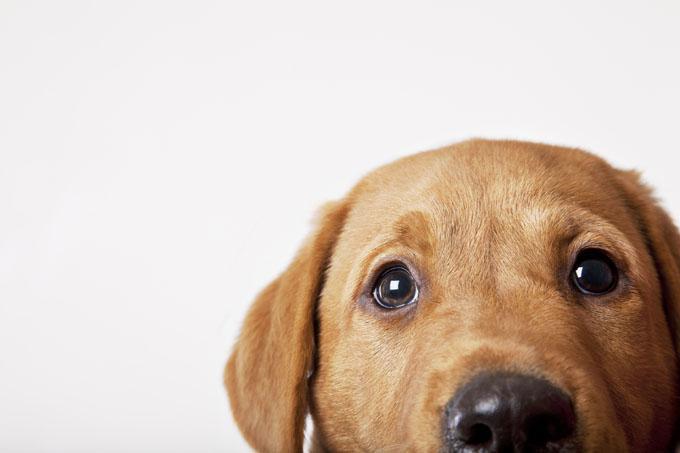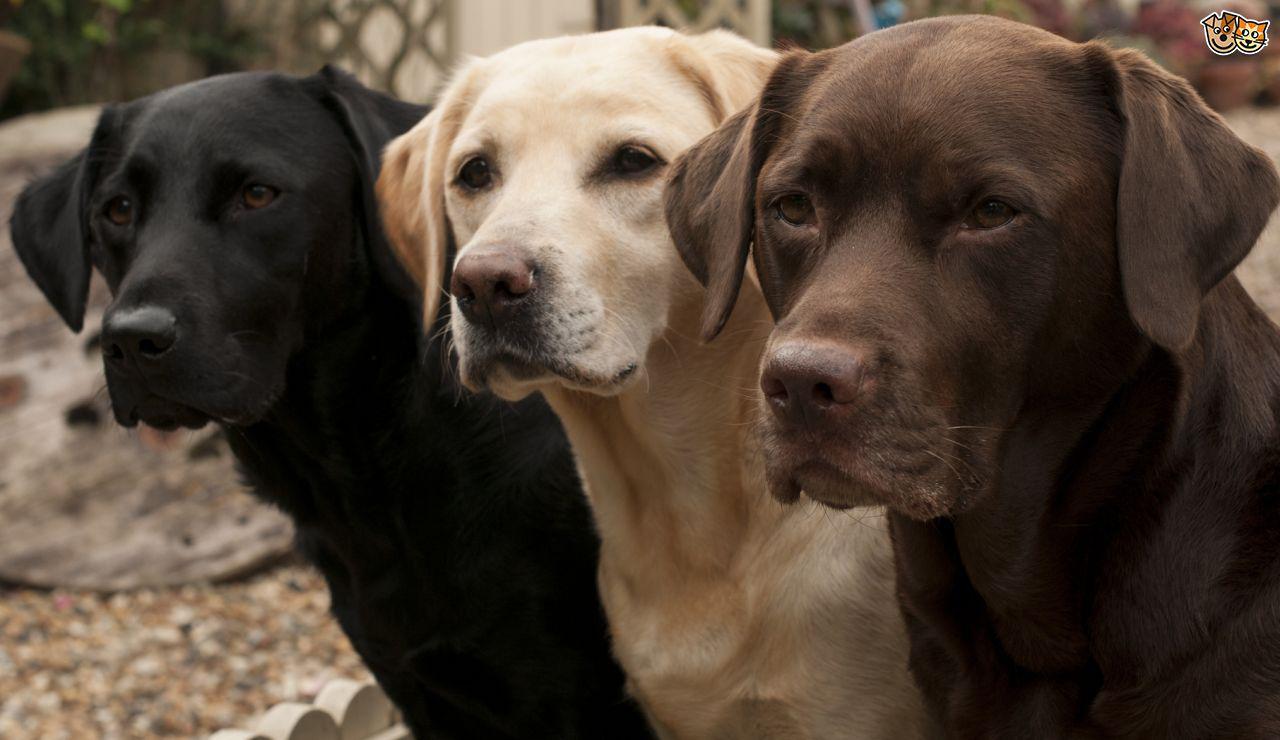The first image is the image on the left, the second image is the image on the right. Considering the images on both sides, is "In one image a group of dogs is four different colors, while in the other image, two dogs have the same coloring." valid? Answer yes or no. No. The first image is the image on the left, the second image is the image on the right. Considering the images on both sides, is "The left image contains more dogs than the right image." valid? Answer yes or no. No. 